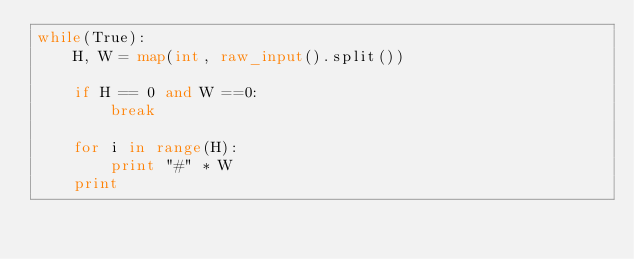<code> <loc_0><loc_0><loc_500><loc_500><_Python_>while(True):
    H, W = map(int, raw_input().split())

    if H == 0 and W ==0:
        break

    for i in range(H):
        print "#" * W
    print</code> 